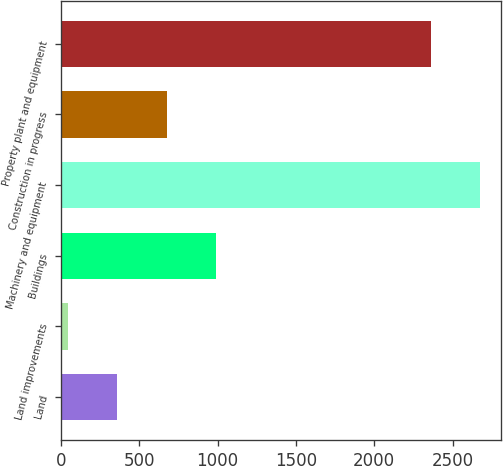Convert chart. <chart><loc_0><loc_0><loc_500><loc_500><bar_chart><fcel>Land<fcel>Land improvements<fcel>Buildings<fcel>Machinery and equipment<fcel>Construction in progress<fcel>Property plant and equipment<nl><fcel>360.5<fcel>45<fcel>991.5<fcel>2677.5<fcel>676<fcel>2362<nl></chart> 